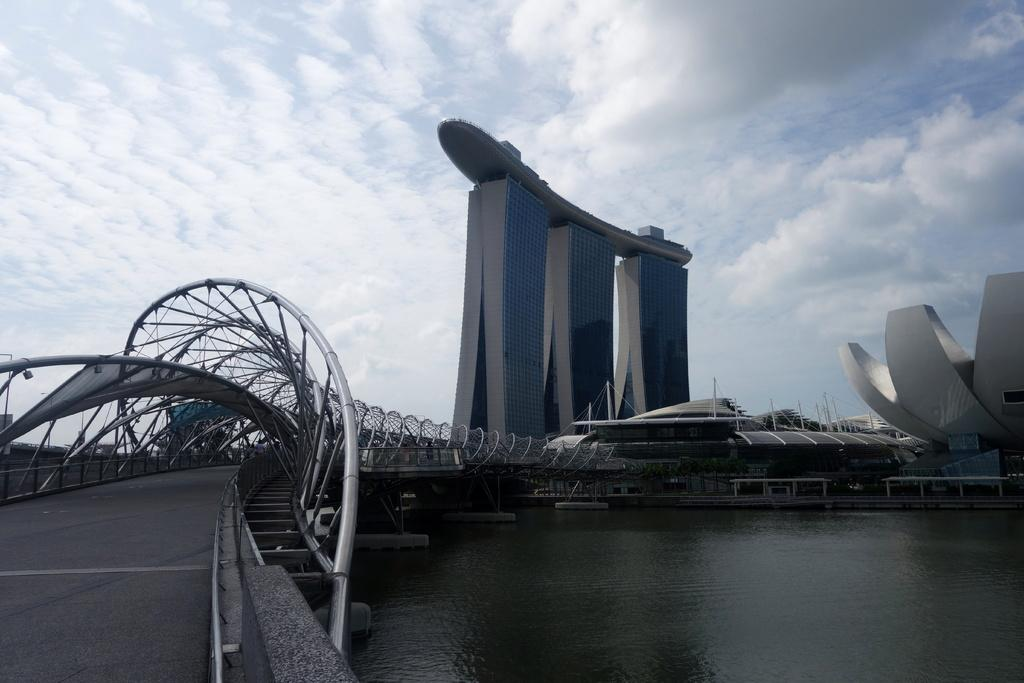What is the main structure in the foreground of the image? There is a bridge in the foreground of the image. What is located under the bridge? There is water under the bridge. What type of structures can be seen in the background of the image? There are buildings in the background of the image, including a skyscraper. What is visible in the sky in the background of the image? The sky is visible in the background of the image, and there are clouds present. Can you tell me how many people are in the group holding a whip in the image? There is no group of people holding a whip present in the image. 